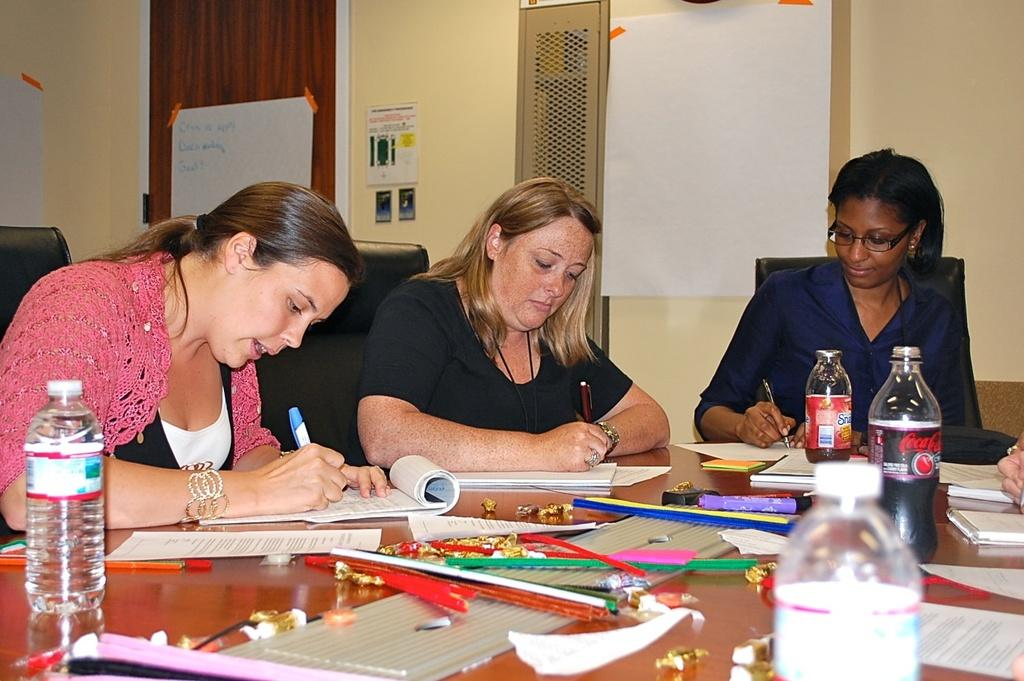How many women are in the image? There are three women in the image. What are the women doing in the image? The women are sitting on chairs and writing on paper. What is the furniture piece on which the women are sitting? There is a wooden table in the image. What items can be seen on the table? A bottle, a cool drink, and sketches are present on the table. What type of shop can be seen in the background of the image? There is no shop visible in the image; it only features the three women, chairs, and table. Can you describe the beam that is supporting the roof in the image? There is no beam present in the image; the focus is on the women, chairs, and table. 